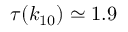<formula> <loc_0><loc_0><loc_500><loc_500>\tau ( k _ { 1 0 } ) \simeq { 1 . 9 }</formula> 